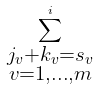Convert formula to latex. <formula><loc_0><loc_0><loc_500><loc_500>\sum _ { \substack { j _ { v } + k _ { v } = s _ { v } \\ v = 1 , \dots , m } } ^ { i }</formula> 